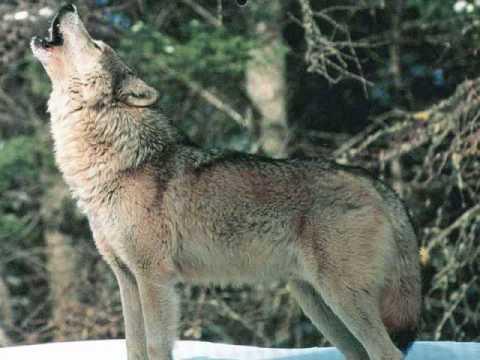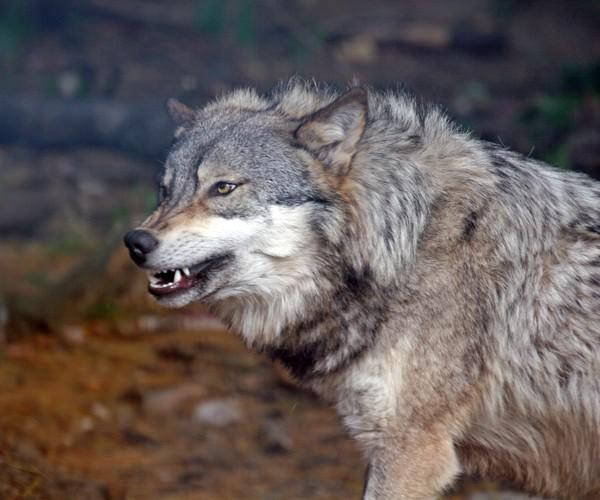The first image is the image on the left, the second image is the image on the right. Assess this claim about the two images: "There are two wolves in the right image.". Correct or not? Answer yes or no. No. 